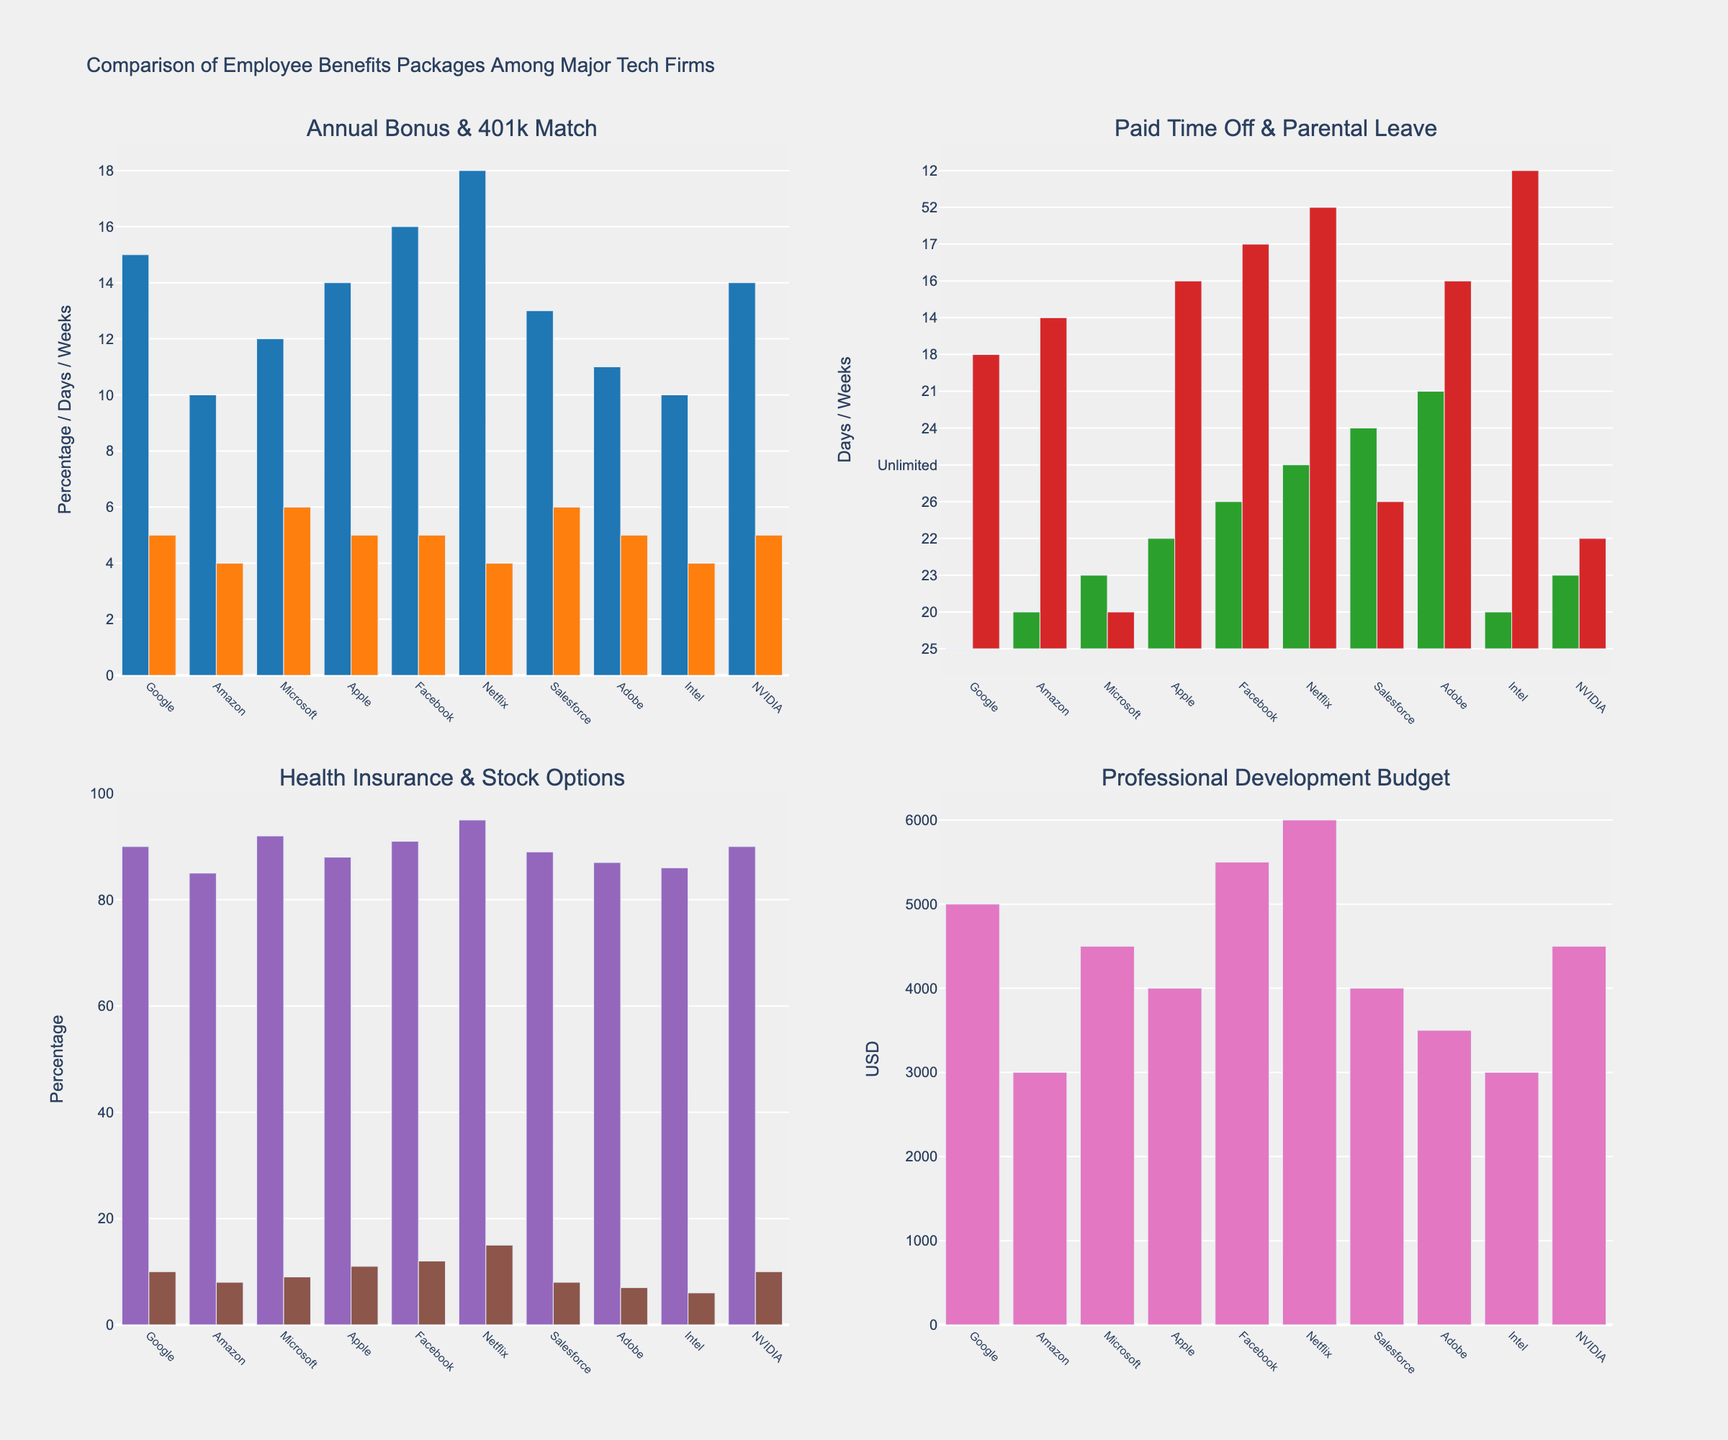What's the company with the highest annual bonus? Look for the tallest bar in the Annual Bonus section. Netflix has the highest bar at 18%.
Answer: Netflix Which company offers the most extensive parental leave? Look for the tallest bar in the Parental Leave section. Netflix has the tallest bar at 52 weeks.
Answer: Netflix What is the total health insurance coverage percentage for Google and Facebook? Check the Health Insurance Coverage bars for Google and Facebook. Google has 90% and Facebook has 91%. Sum them up (90 + 91).
Answer: 181% Which companies offer 5% 401k match? Check the 401k Match section and find the bars that reach 5%. Companies with this value are Google, Apple, Facebook, Adobe, and NVIDIA.
Answer: Google, Apple, Facebook, Adobe, NVIDIA What's the difference in professional development budget between Google and Amazon? Find the Prof Dev Budget bars for Google and Amazon. Google's bar is at $5000, Amazon's is at $3000. Subtract 3000 from 5000.
Answer: $2000 Which company offers the lowest number of paid time off days? Look for the shortest bar in the Paid Time Off section. Amazon and Intel are the shortest at 20 days.
Answer: Amazon, Intel What's the combined percentage of stock options for Microsoft and NVIDIA? Check the Stock Options bars for Microsoft and NVIDIA. Microsoft has 9% and NVIDIA has 10%. Sum them up (9 + 10).
Answer: 19% How do Apple and Amazon compare in terms of parental leave? Compare the bars for Parental Leave of Apple and Amazon. Apple offers 16 weeks while Amazon offers 14 weeks.
Answer: Apple offers 2 more weeks Which company provides the second highest health insurance coverage? Identify the bars with the highest value in Health Insurance Coverage and find the second highest. Netflix is highest at 95%, and Facebook is the second at 91%.
Answer: Facebook What is the average 401k match percentage among the listed companies? Add the 401k Match percentages for all companies (5 + 4 + 6 + 5 + 5 + 4 + 6 + 5 + 4 + 5 = 49) and divide by the number of companies (10).
Answer: 4.9% 